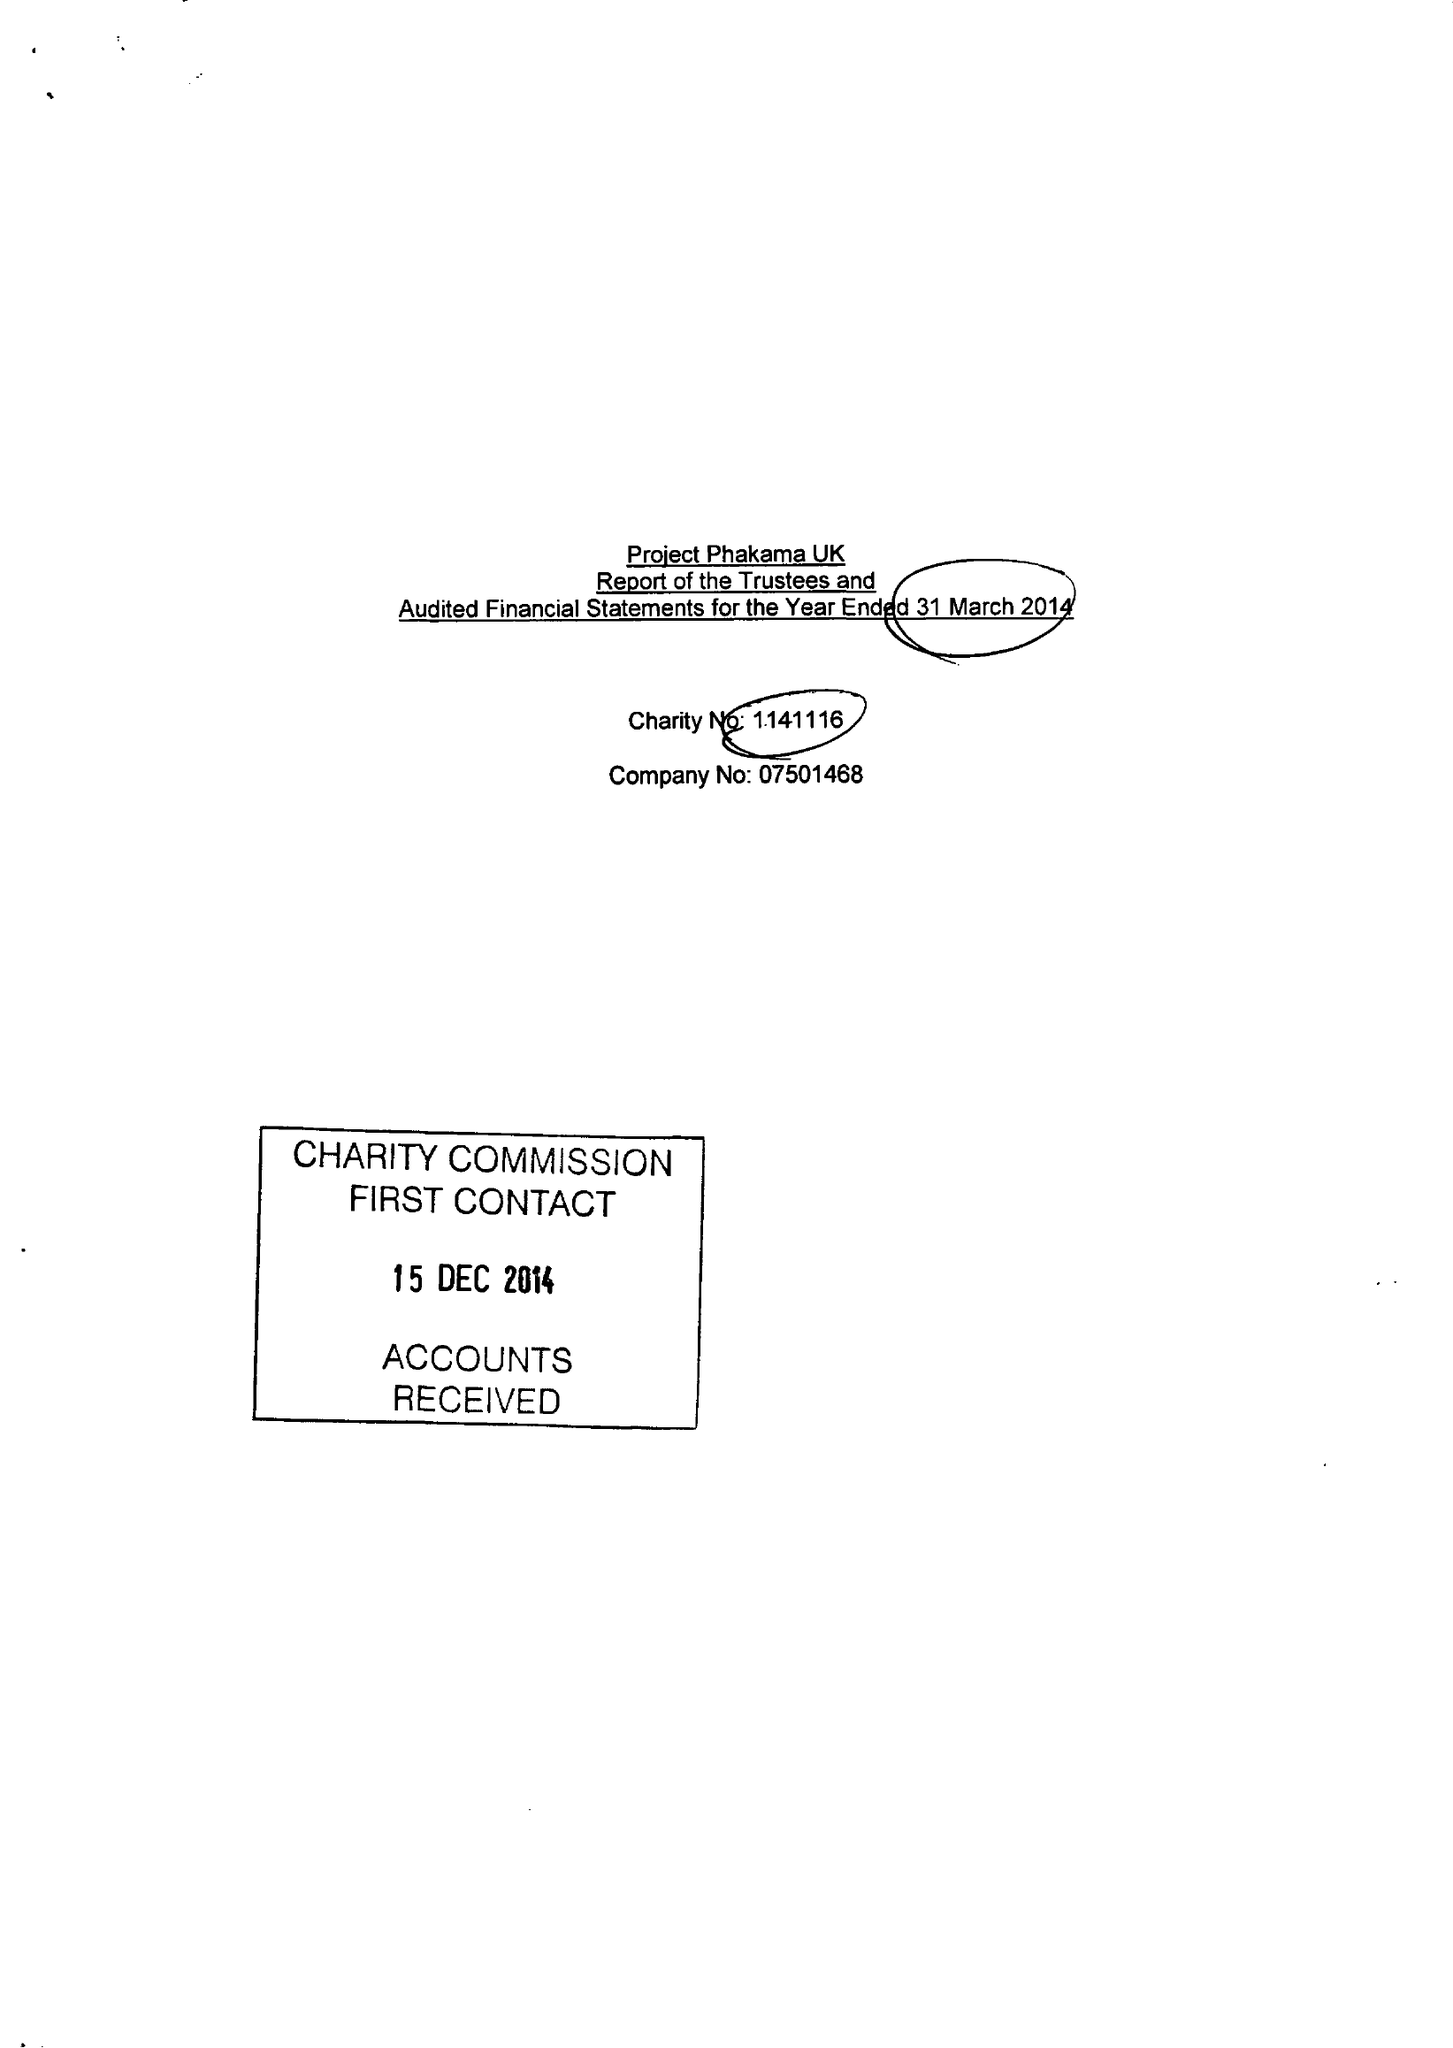What is the value for the address__postcode?
Answer the question using a single word or phrase. E1 4NS 